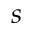<formula> <loc_0><loc_0><loc_500><loc_500>s</formula> 